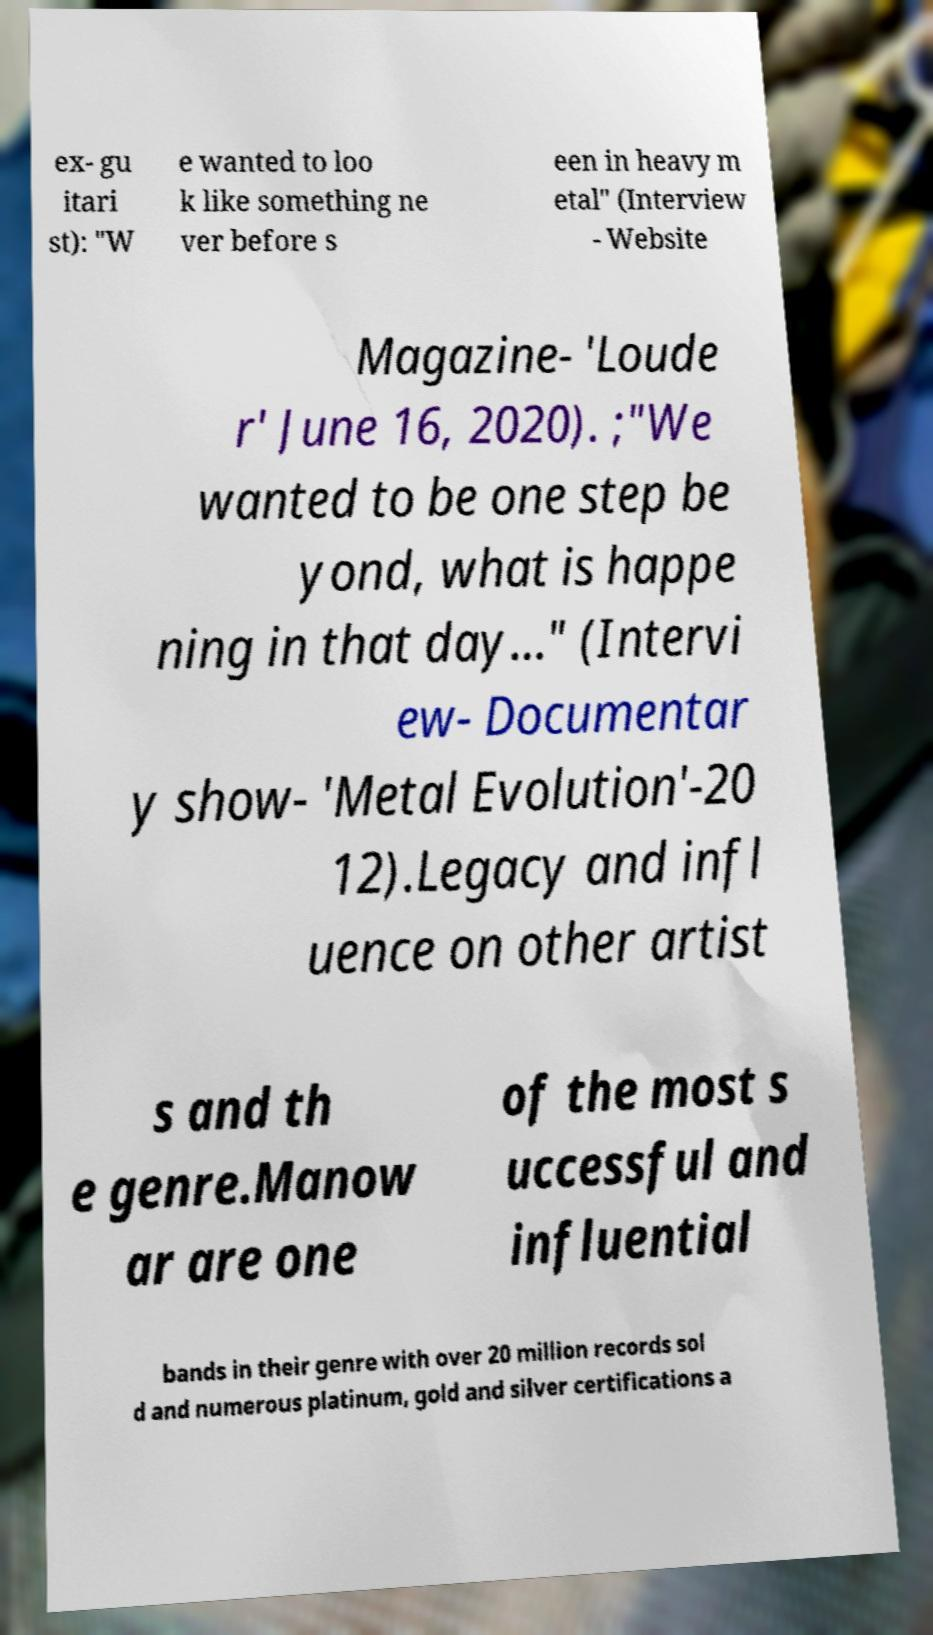There's text embedded in this image that I need extracted. Can you transcribe it verbatim? ex- gu itari st): "W e wanted to loo k like something ne ver before s een in heavy m etal" (Interview - Website Magazine- 'Loude r' June 16, 2020). ;"We wanted to be one step be yond, what is happe ning in that day…" (Intervi ew- Documentar y show- 'Metal Evolution'-20 12).Legacy and infl uence on other artist s and th e genre.Manow ar are one of the most s uccessful and influential bands in their genre with over 20 million records sol d and numerous platinum, gold and silver certifications a 